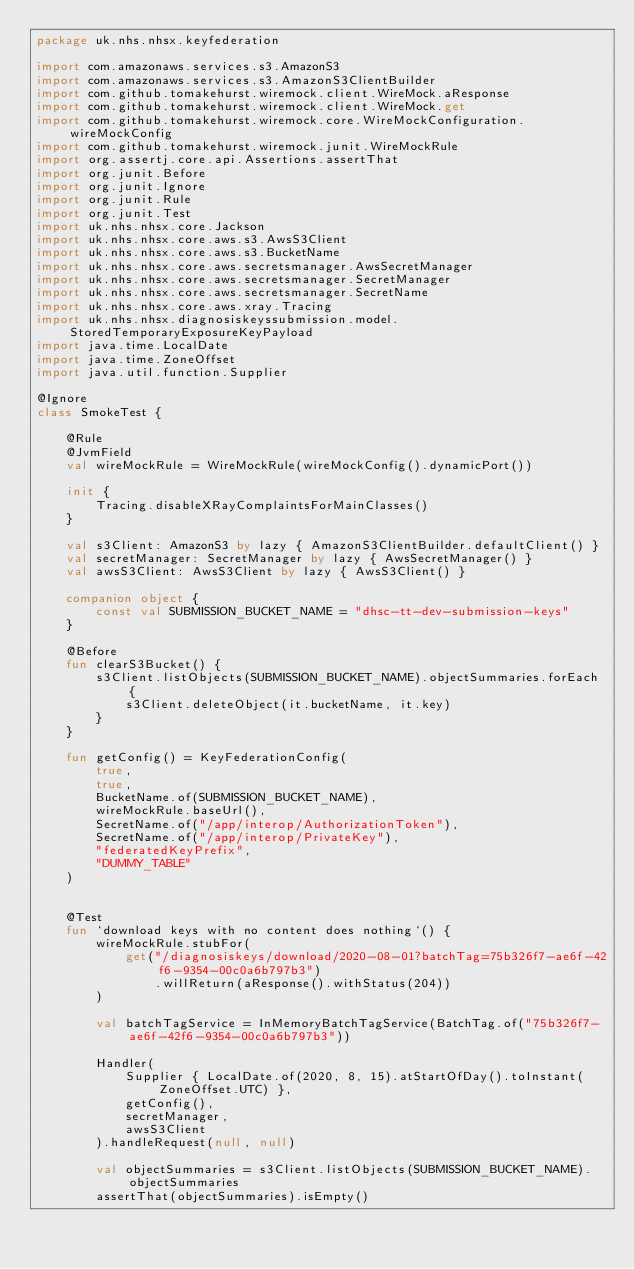Convert code to text. <code><loc_0><loc_0><loc_500><loc_500><_Kotlin_>package uk.nhs.nhsx.keyfederation

import com.amazonaws.services.s3.AmazonS3
import com.amazonaws.services.s3.AmazonS3ClientBuilder
import com.github.tomakehurst.wiremock.client.WireMock.aResponse
import com.github.tomakehurst.wiremock.client.WireMock.get
import com.github.tomakehurst.wiremock.core.WireMockConfiguration.wireMockConfig
import com.github.tomakehurst.wiremock.junit.WireMockRule
import org.assertj.core.api.Assertions.assertThat
import org.junit.Before
import org.junit.Ignore
import org.junit.Rule
import org.junit.Test
import uk.nhs.nhsx.core.Jackson
import uk.nhs.nhsx.core.aws.s3.AwsS3Client
import uk.nhs.nhsx.core.aws.s3.BucketName
import uk.nhs.nhsx.core.aws.secretsmanager.AwsSecretManager
import uk.nhs.nhsx.core.aws.secretsmanager.SecretManager
import uk.nhs.nhsx.core.aws.secretsmanager.SecretName
import uk.nhs.nhsx.core.aws.xray.Tracing
import uk.nhs.nhsx.diagnosiskeyssubmission.model.StoredTemporaryExposureKeyPayload
import java.time.LocalDate
import java.time.ZoneOffset
import java.util.function.Supplier

@Ignore
class SmokeTest {

    @Rule
    @JvmField
    val wireMockRule = WireMockRule(wireMockConfig().dynamicPort())

    init {
        Tracing.disableXRayComplaintsForMainClasses()
    }

    val s3Client: AmazonS3 by lazy { AmazonS3ClientBuilder.defaultClient() }
    val secretManager: SecretManager by lazy { AwsSecretManager() }
    val awsS3Client: AwsS3Client by lazy { AwsS3Client() }

    companion object {
        const val SUBMISSION_BUCKET_NAME = "dhsc-tt-dev-submission-keys"
    }

    @Before
    fun clearS3Bucket() {
        s3Client.listObjects(SUBMISSION_BUCKET_NAME).objectSummaries.forEach {
            s3Client.deleteObject(it.bucketName, it.key)
        }
    }

    fun getConfig() = KeyFederationConfig(
        true,
        true,
        BucketName.of(SUBMISSION_BUCKET_NAME),
        wireMockRule.baseUrl(),
        SecretName.of("/app/interop/AuthorizationToken"),
        SecretName.of("/app/interop/PrivateKey"),
        "federatedKeyPrefix",
        "DUMMY_TABLE"
    )


    @Test
    fun `download keys with no content does nothing`() {
        wireMockRule.stubFor(
            get("/diagnosiskeys/download/2020-08-01?batchTag=75b326f7-ae6f-42f6-9354-00c0a6b797b3")
                .willReturn(aResponse().withStatus(204))
        )

        val batchTagService = InMemoryBatchTagService(BatchTag.of("75b326f7-ae6f-42f6-9354-00c0a6b797b3"))

        Handler(
            Supplier { LocalDate.of(2020, 8, 15).atStartOfDay().toInstant(ZoneOffset.UTC) },
            getConfig(),
            secretManager,
            awsS3Client
        ).handleRequest(null, null)

        val objectSummaries = s3Client.listObjects(SUBMISSION_BUCKET_NAME).objectSummaries
        assertThat(objectSummaries).isEmpty()</code> 